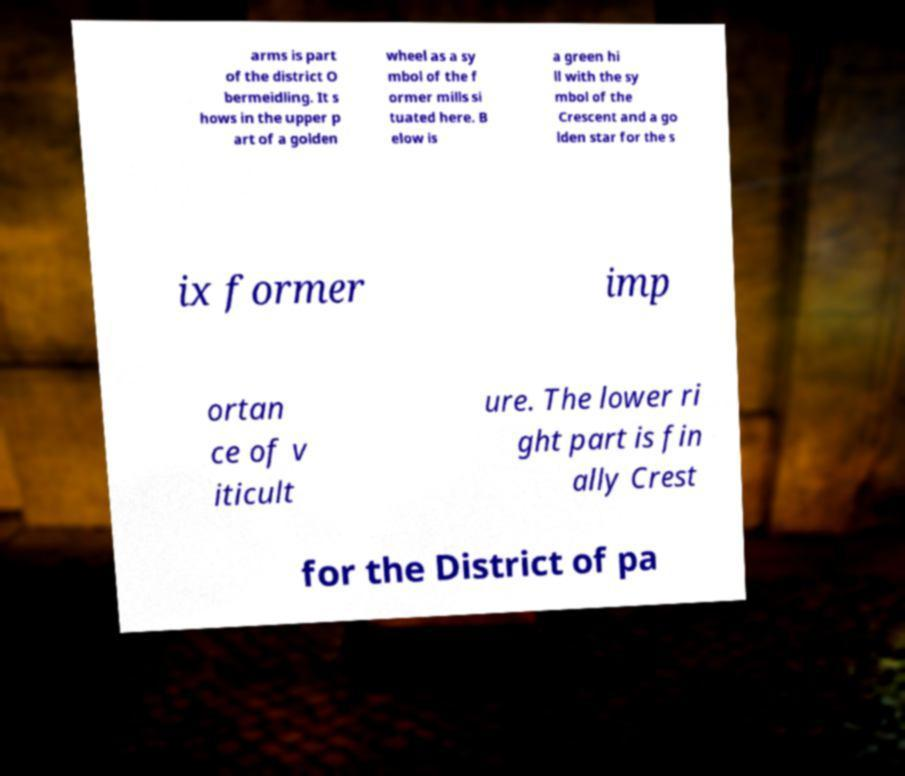Can you accurately transcribe the text from the provided image for me? arms is part of the district O bermeidling. It s hows in the upper p art of a golden wheel as a sy mbol of the f ormer mills si tuated here. B elow is a green hi ll with the sy mbol of the Crescent and a go lden star for the s ix former imp ortan ce of v iticult ure. The lower ri ght part is fin ally Crest for the District of pa 